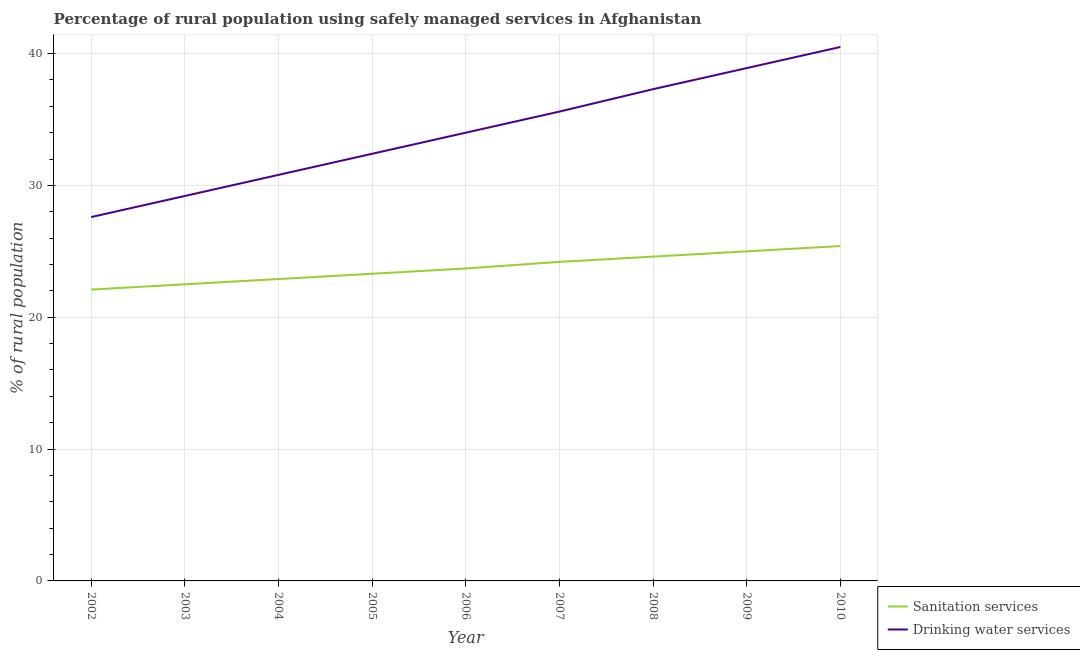How many different coloured lines are there?
Give a very brief answer. 2. Is the number of lines equal to the number of legend labels?
Your answer should be very brief. Yes. What is the percentage of rural population who used drinking water services in 2002?
Give a very brief answer. 27.6. Across all years, what is the maximum percentage of rural population who used drinking water services?
Offer a terse response. 40.5. Across all years, what is the minimum percentage of rural population who used sanitation services?
Your answer should be very brief. 22.1. What is the total percentage of rural population who used drinking water services in the graph?
Your response must be concise. 306.3. What is the difference between the percentage of rural population who used drinking water services in 2002 and that in 2006?
Your answer should be compact. -6.4. What is the difference between the percentage of rural population who used sanitation services in 2003 and the percentage of rural population who used drinking water services in 2009?
Ensure brevity in your answer.  -16.4. What is the average percentage of rural population who used drinking water services per year?
Make the answer very short. 34.03. In how many years, is the percentage of rural population who used drinking water services greater than 22 %?
Your answer should be compact. 9. What is the ratio of the percentage of rural population who used drinking water services in 2005 to that in 2008?
Make the answer very short. 0.87. Is the difference between the percentage of rural population who used drinking water services in 2007 and 2009 greater than the difference between the percentage of rural population who used sanitation services in 2007 and 2009?
Provide a short and direct response. No. What is the difference between the highest and the second highest percentage of rural population who used sanitation services?
Make the answer very short. 0.4. What is the difference between the highest and the lowest percentage of rural population who used drinking water services?
Your response must be concise. 12.9. In how many years, is the percentage of rural population who used sanitation services greater than the average percentage of rural population who used sanitation services taken over all years?
Your answer should be compact. 4. Is the sum of the percentage of rural population who used sanitation services in 2004 and 2009 greater than the maximum percentage of rural population who used drinking water services across all years?
Keep it short and to the point. Yes. Is the percentage of rural population who used drinking water services strictly less than the percentage of rural population who used sanitation services over the years?
Offer a terse response. No. How many years are there in the graph?
Your response must be concise. 9. What is the difference between two consecutive major ticks on the Y-axis?
Make the answer very short. 10. Where does the legend appear in the graph?
Your response must be concise. Bottom right. How many legend labels are there?
Your answer should be compact. 2. What is the title of the graph?
Offer a very short reply. Percentage of rural population using safely managed services in Afghanistan. What is the label or title of the Y-axis?
Offer a terse response. % of rural population. What is the % of rural population in Sanitation services in 2002?
Your response must be concise. 22.1. What is the % of rural population in Drinking water services in 2002?
Your answer should be compact. 27.6. What is the % of rural population in Sanitation services in 2003?
Give a very brief answer. 22.5. What is the % of rural population of Drinking water services in 2003?
Provide a short and direct response. 29.2. What is the % of rural population of Sanitation services in 2004?
Provide a succinct answer. 22.9. What is the % of rural population in Drinking water services in 2004?
Offer a very short reply. 30.8. What is the % of rural population of Sanitation services in 2005?
Offer a terse response. 23.3. What is the % of rural population of Drinking water services in 2005?
Provide a short and direct response. 32.4. What is the % of rural population of Sanitation services in 2006?
Make the answer very short. 23.7. What is the % of rural population of Sanitation services in 2007?
Make the answer very short. 24.2. What is the % of rural population of Drinking water services in 2007?
Your answer should be very brief. 35.6. What is the % of rural population in Sanitation services in 2008?
Your answer should be very brief. 24.6. What is the % of rural population in Drinking water services in 2008?
Your answer should be compact. 37.3. What is the % of rural population of Sanitation services in 2009?
Your response must be concise. 25. What is the % of rural population in Drinking water services in 2009?
Your answer should be very brief. 38.9. What is the % of rural population in Sanitation services in 2010?
Keep it short and to the point. 25.4. What is the % of rural population of Drinking water services in 2010?
Ensure brevity in your answer.  40.5. Across all years, what is the maximum % of rural population in Sanitation services?
Your response must be concise. 25.4. Across all years, what is the maximum % of rural population in Drinking water services?
Make the answer very short. 40.5. Across all years, what is the minimum % of rural population in Sanitation services?
Make the answer very short. 22.1. Across all years, what is the minimum % of rural population of Drinking water services?
Your answer should be very brief. 27.6. What is the total % of rural population of Sanitation services in the graph?
Keep it short and to the point. 213.7. What is the total % of rural population of Drinking water services in the graph?
Provide a succinct answer. 306.3. What is the difference between the % of rural population in Sanitation services in 2002 and that in 2003?
Offer a terse response. -0.4. What is the difference between the % of rural population in Drinking water services in 2002 and that in 2003?
Give a very brief answer. -1.6. What is the difference between the % of rural population of Drinking water services in 2002 and that in 2005?
Your answer should be compact. -4.8. What is the difference between the % of rural population of Sanitation services in 2002 and that in 2007?
Your response must be concise. -2.1. What is the difference between the % of rural population of Drinking water services in 2002 and that in 2007?
Keep it short and to the point. -8. What is the difference between the % of rural population in Drinking water services in 2002 and that in 2009?
Provide a short and direct response. -11.3. What is the difference between the % of rural population in Drinking water services in 2002 and that in 2010?
Provide a short and direct response. -12.9. What is the difference between the % of rural population of Sanitation services in 2003 and that in 2004?
Ensure brevity in your answer.  -0.4. What is the difference between the % of rural population in Sanitation services in 2003 and that in 2005?
Keep it short and to the point. -0.8. What is the difference between the % of rural population of Drinking water services in 2003 and that in 2005?
Offer a very short reply. -3.2. What is the difference between the % of rural population of Sanitation services in 2003 and that in 2006?
Ensure brevity in your answer.  -1.2. What is the difference between the % of rural population in Sanitation services in 2003 and that in 2009?
Offer a terse response. -2.5. What is the difference between the % of rural population in Drinking water services in 2003 and that in 2010?
Ensure brevity in your answer.  -11.3. What is the difference between the % of rural population in Sanitation services in 2004 and that in 2006?
Your response must be concise. -0.8. What is the difference between the % of rural population of Drinking water services in 2004 and that in 2006?
Your answer should be very brief. -3.2. What is the difference between the % of rural population of Drinking water services in 2004 and that in 2008?
Keep it short and to the point. -6.5. What is the difference between the % of rural population in Sanitation services in 2004 and that in 2009?
Ensure brevity in your answer.  -2.1. What is the difference between the % of rural population in Drinking water services in 2004 and that in 2009?
Provide a succinct answer. -8.1. What is the difference between the % of rural population of Drinking water services in 2004 and that in 2010?
Provide a short and direct response. -9.7. What is the difference between the % of rural population in Sanitation services in 2005 and that in 2006?
Your response must be concise. -0.4. What is the difference between the % of rural population in Sanitation services in 2005 and that in 2009?
Provide a short and direct response. -1.7. What is the difference between the % of rural population of Sanitation services in 2006 and that in 2007?
Your answer should be very brief. -0.5. What is the difference between the % of rural population in Sanitation services in 2006 and that in 2008?
Give a very brief answer. -0.9. What is the difference between the % of rural population in Drinking water services in 2006 and that in 2009?
Your answer should be very brief. -4.9. What is the difference between the % of rural population of Sanitation services in 2006 and that in 2010?
Ensure brevity in your answer.  -1.7. What is the difference between the % of rural population in Drinking water services in 2006 and that in 2010?
Give a very brief answer. -6.5. What is the difference between the % of rural population of Drinking water services in 2007 and that in 2008?
Your answer should be very brief. -1.7. What is the difference between the % of rural population of Sanitation services in 2007 and that in 2010?
Your answer should be very brief. -1.2. What is the difference between the % of rural population of Drinking water services in 2008 and that in 2009?
Provide a short and direct response. -1.6. What is the difference between the % of rural population of Sanitation services in 2008 and that in 2010?
Ensure brevity in your answer.  -0.8. What is the difference between the % of rural population of Drinking water services in 2008 and that in 2010?
Your answer should be compact. -3.2. What is the difference between the % of rural population in Sanitation services in 2002 and the % of rural population in Drinking water services in 2003?
Make the answer very short. -7.1. What is the difference between the % of rural population of Sanitation services in 2002 and the % of rural population of Drinking water services in 2005?
Provide a succinct answer. -10.3. What is the difference between the % of rural population of Sanitation services in 2002 and the % of rural population of Drinking water services in 2008?
Your answer should be very brief. -15.2. What is the difference between the % of rural population of Sanitation services in 2002 and the % of rural population of Drinking water services in 2009?
Give a very brief answer. -16.8. What is the difference between the % of rural population of Sanitation services in 2002 and the % of rural population of Drinking water services in 2010?
Give a very brief answer. -18.4. What is the difference between the % of rural population of Sanitation services in 2003 and the % of rural population of Drinking water services in 2004?
Ensure brevity in your answer.  -8.3. What is the difference between the % of rural population in Sanitation services in 2003 and the % of rural population in Drinking water services in 2005?
Offer a very short reply. -9.9. What is the difference between the % of rural population in Sanitation services in 2003 and the % of rural population in Drinking water services in 2007?
Keep it short and to the point. -13.1. What is the difference between the % of rural population in Sanitation services in 2003 and the % of rural population in Drinking water services in 2008?
Your answer should be very brief. -14.8. What is the difference between the % of rural population of Sanitation services in 2003 and the % of rural population of Drinking water services in 2009?
Your answer should be very brief. -16.4. What is the difference between the % of rural population of Sanitation services in 2003 and the % of rural population of Drinking water services in 2010?
Your answer should be very brief. -18. What is the difference between the % of rural population of Sanitation services in 2004 and the % of rural population of Drinking water services in 2005?
Offer a terse response. -9.5. What is the difference between the % of rural population of Sanitation services in 2004 and the % of rural population of Drinking water services in 2006?
Give a very brief answer. -11.1. What is the difference between the % of rural population in Sanitation services in 2004 and the % of rural population in Drinking water services in 2007?
Ensure brevity in your answer.  -12.7. What is the difference between the % of rural population in Sanitation services in 2004 and the % of rural population in Drinking water services in 2008?
Your answer should be very brief. -14.4. What is the difference between the % of rural population in Sanitation services in 2004 and the % of rural population in Drinking water services in 2010?
Offer a very short reply. -17.6. What is the difference between the % of rural population of Sanitation services in 2005 and the % of rural population of Drinking water services in 2008?
Your response must be concise. -14. What is the difference between the % of rural population of Sanitation services in 2005 and the % of rural population of Drinking water services in 2009?
Provide a short and direct response. -15.6. What is the difference between the % of rural population in Sanitation services in 2005 and the % of rural population in Drinking water services in 2010?
Provide a short and direct response. -17.2. What is the difference between the % of rural population of Sanitation services in 2006 and the % of rural population of Drinking water services in 2007?
Give a very brief answer. -11.9. What is the difference between the % of rural population of Sanitation services in 2006 and the % of rural population of Drinking water services in 2009?
Make the answer very short. -15.2. What is the difference between the % of rural population of Sanitation services in 2006 and the % of rural population of Drinking water services in 2010?
Provide a succinct answer. -16.8. What is the difference between the % of rural population in Sanitation services in 2007 and the % of rural population in Drinking water services in 2008?
Provide a succinct answer. -13.1. What is the difference between the % of rural population of Sanitation services in 2007 and the % of rural population of Drinking water services in 2009?
Offer a terse response. -14.7. What is the difference between the % of rural population of Sanitation services in 2007 and the % of rural population of Drinking water services in 2010?
Provide a short and direct response. -16.3. What is the difference between the % of rural population in Sanitation services in 2008 and the % of rural population in Drinking water services in 2009?
Your answer should be very brief. -14.3. What is the difference between the % of rural population of Sanitation services in 2008 and the % of rural population of Drinking water services in 2010?
Offer a very short reply. -15.9. What is the difference between the % of rural population in Sanitation services in 2009 and the % of rural population in Drinking water services in 2010?
Offer a terse response. -15.5. What is the average % of rural population of Sanitation services per year?
Give a very brief answer. 23.74. What is the average % of rural population of Drinking water services per year?
Provide a succinct answer. 34.03. In the year 2002, what is the difference between the % of rural population in Sanitation services and % of rural population in Drinking water services?
Keep it short and to the point. -5.5. In the year 2003, what is the difference between the % of rural population of Sanitation services and % of rural population of Drinking water services?
Offer a very short reply. -6.7. In the year 2004, what is the difference between the % of rural population in Sanitation services and % of rural population in Drinking water services?
Offer a very short reply. -7.9. In the year 2006, what is the difference between the % of rural population in Sanitation services and % of rural population in Drinking water services?
Provide a succinct answer. -10.3. In the year 2009, what is the difference between the % of rural population of Sanitation services and % of rural population of Drinking water services?
Offer a terse response. -13.9. In the year 2010, what is the difference between the % of rural population of Sanitation services and % of rural population of Drinking water services?
Your answer should be very brief. -15.1. What is the ratio of the % of rural population in Sanitation services in 2002 to that in 2003?
Provide a short and direct response. 0.98. What is the ratio of the % of rural population in Drinking water services in 2002 to that in 2003?
Provide a short and direct response. 0.95. What is the ratio of the % of rural population in Sanitation services in 2002 to that in 2004?
Your answer should be compact. 0.97. What is the ratio of the % of rural population in Drinking water services in 2002 to that in 2004?
Offer a very short reply. 0.9. What is the ratio of the % of rural population of Sanitation services in 2002 to that in 2005?
Keep it short and to the point. 0.95. What is the ratio of the % of rural population in Drinking water services in 2002 to that in 2005?
Offer a very short reply. 0.85. What is the ratio of the % of rural population in Sanitation services in 2002 to that in 2006?
Your response must be concise. 0.93. What is the ratio of the % of rural population in Drinking water services in 2002 to that in 2006?
Provide a succinct answer. 0.81. What is the ratio of the % of rural population in Sanitation services in 2002 to that in 2007?
Offer a terse response. 0.91. What is the ratio of the % of rural population of Drinking water services in 2002 to that in 2007?
Provide a short and direct response. 0.78. What is the ratio of the % of rural population of Sanitation services in 2002 to that in 2008?
Keep it short and to the point. 0.9. What is the ratio of the % of rural population in Drinking water services in 2002 to that in 2008?
Give a very brief answer. 0.74. What is the ratio of the % of rural population in Sanitation services in 2002 to that in 2009?
Provide a short and direct response. 0.88. What is the ratio of the % of rural population of Drinking water services in 2002 to that in 2009?
Provide a short and direct response. 0.71. What is the ratio of the % of rural population of Sanitation services in 2002 to that in 2010?
Your answer should be very brief. 0.87. What is the ratio of the % of rural population of Drinking water services in 2002 to that in 2010?
Provide a succinct answer. 0.68. What is the ratio of the % of rural population of Sanitation services in 2003 to that in 2004?
Provide a succinct answer. 0.98. What is the ratio of the % of rural population in Drinking water services in 2003 to that in 2004?
Make the answer very short. 0.95. What is the ratio of the % of rural population of Sanitation services in 2003 to that in 2005?
Make the answer very short. 0.97. What is the ratio of the % of rural population of Drinking water services in 2003 to that in 2005?
Make the answer very short. 0.9. What is the ratio of the % of rural population of Sanitation services in 2003 to that in 2006?
Offer a terse response. 0.95. What is the ratio of the % of rural population of Drinking water services in 2003 to that in 2006?
Give a very brief answer. 0.86. What is the ratio of the % of rural population in Sanitation services in 2003 to that in 2007?
Provide a succinct answer. 0.93. What is the ratio of the % of rural population of Drinking water services in 2003 to that in 2007?
Your answer should be compact. 0.82. What is the ratio of the % of rural population of Sanitation services in 2003 to that in 2008?
Your answer should be very brief. 0.91. What is the ratio of the % of rural population in Drinking water services in 2003 to that in 2008?
Your response must be concise. 0.78. What is the ratio of the % of rural population in Drinking water services in 2003 to that in 2009?
Provide a short and direct response. 0.75. What is the ratio of the % of rural population of Sanitation services in 2003 to that in 2010?
Offer a terse response. 0.89. What is the ratio of the % of rural population of Drinking water services in 2003 to that in 2010?
Ensure brevity in your answer.  0.72. What is the ratio of the % of rural population of Sanitation services in 2004 to that in 2005?
Ensure brevity in your answer.  0.98. What is the ratio of the % of rural population of Drinking water services in 2004 to that in 2005?
Your answer should be compact. 0.95. What is the ratio of the % of rural population of Sanitation services in 2004 to that in 2006?
Provide a succinct answer. 0.97. What is the ratio of the % of rural population in Drinking water services in 2004 to that in 2006?
Provide a short and direct response. 0.91. What is the ratio of the % of rural population in Sanitation services in 2004 to that in 2007?
Keep it short and to the point. 0.95. What is the ratio of the % of rural population of Drinking water services in 2004 to that in 2007?
Offer a very short reply. 0.87. What is the ratio of the % of rural population of Sanitation services in 2004 to that in 2008?
Your response must be concise. 0.93. What is the ratio of the % of rural population in Drinking water services in 2004 to that in 2008?
Ensure brevity in your answer.  0.83. What is the ratio of the % of rural population in Sanitation services in 2004 to that in 2009?
Offer a very short reply. 0.92. What is the ratio of the % of rural population in Drinking water services in 2004 to that in 2009?
Offer a very short reply. 0.79. What is the ratio of the % of rural population of Sanitation services in 2004 to that in 2010?
Your response must be concise. 0.9. What is the ratio of the % of rural population in Drinking water services in 2004 to that in 2010?
Your answer should be compact. 0.76. What is the ratio of the % of rural population of Sanitation services in 2005 to that in 2006?
Make the answer very short. 0.98. What is the ratio of the % of rural population of Drinking water services in 2005 to that in 2006?
Your response must be concise. 0.95. What is the ratio of the % of rural population of Sanitation services in 2005 to that in 2007?
Ensure brevity in your answer.  0.96. What is the ratio of the % of rural population in Drinking water services in 2005 to that in 2007?
Your answer should be very brief. 0.91. What is the ratio of the % of rural population in Sanitation services in 2005 to that in 2008?
Give a very brief answer. 0.95. What is the ratio of the % of rural population of Drinking water services in 2005 to that in 2008?
Offer a terse response. 0.87. What is the ratio of the % of rural population of Sanitation services in 2005 to that in 2009?
Provide a succinct answer. 0.93. What is the ratio of the % of rural population in Drinking water services in 2005 to that in 2009?
Your response must be concise. 0.83. What is the ratio of the % of rural population in Sanitation services in 2005 to that in 2010?
Your response must be concise. 0.92. What is the ratio of the % of rural population of Sanitation services in 2006 to that in 2007?
Ensure brevity in your answer.  0.98. What is the ratio of the % of rural population in Drinking water services in 2006 to that in 2007?
Provide a short and direct response. 0.96. What is the ratio of the % of rural population of Sanitation services in 2006 to that in 2008?
Provide a short and direct response. 0.96. What is the ratio of the % of rural population in Drinking water services in 2006 to that in 2008?
Make the answer very short. 0.91. What is the ratio of the % of rural population of Sanitation services in 2006 to that in 2009?
Keep it short and to the point. 0.95. What is the ratio of the % of rural population in Drinking water services in 2006 to that in 2009?
Offer a terse response. 0.87. What is the ratio of the % of rural population in Sanitation services in 2006 to that in 2010?
Your answer should be compact. 0.93. What is the ratio of the % of rural population in Drinking water services in 2006 to that in 2010?
Your answer should be compact. 0.84. What is the ratio of the % of rural population of Sanitation services in 2007 to that in 2008?
Provide a succinct answer. 0.98. What is the ratio of the % of rural population of Drinking water services in 2007 to that in 2008?
Your answer should be very brief. 0.95. What is the ratio of the % of rural population of Drinking water services in 2007 to that in 2009?
Your response must be concise. 0.92. What is the ratio of the % of rural population of Sanitation services in 2007 to that in 2010?
Make the answer very short. 0.95. What is the ratio of the % of rural population in Drinking water services in 2007 to that in 2010?
Provide a succinct answer. 0.88. What is the ratio of the % of rural population in Drinking water services in 2008 to that in 2009?
Offer a terse response. 0.96. What is the ratio of the % of rural population in Sanitation services in 2008 to that in 2010?
Keep it short and to the point. 0.97. What is the ratio of the % of rural population in Drinking water services in 2008 to that in 2010?
Your answer should be very brief. 0.92. What is the ratio of the % of rural population in Sanitation services in 2009 to that in 2010?
Your answer should be compact. 0.98. What is the ratio of the % of rural population in Drinking water services in 2009 to that in 2010?
Offer a very short reply. 0.96. What is the difference between the highest and the second highest % of rural population in Drinking water services?
Offer a terse response. 1.6. What is the difference between the highest and the lowest % of rural population in Drinking water services?
Make the answer very short. 12.9. 